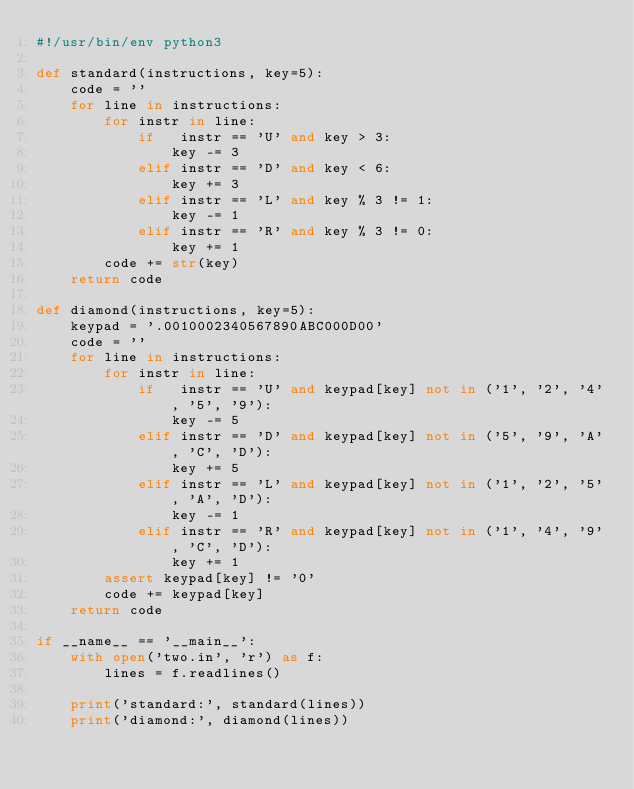Convert code to text. <code><loc_0><loc_0><loc_500><loc_500><_Python_>#!/usr/bin/env python3

def standard(instructions, key=5):
    code = ''
    for line in instructions:
        for instr in line:
            if   instr == 'U' and key > 3:
                key -= 3
            elif instr == 'D' and key < 6:
                key += 3
            elif instr == 'L' and key % 3 != 1:
                key -= 1
            elif instr == 'R' and key % 3 != 0:
                key += 1
        code += str(key)
    return code

def diamond(instructions, key=5):
    keypad = '.0010002340567890ABC000D00'
    code = ''
    for line in instructions:
        for instr in line:
            if   instr == 'U' and keypad[key] not in ('1', '2', '4', '5', '9'):
                key -= 5
            elif instr == 'D' and keypad[key] not in ('5', '9', 'A', 'C', 'D'):
                key += 5
            elif instr == 'L' and keypad[key] not in ('1', '2', '5', 'A', 'D'):
                key -= 1
            elif instr == 'R' and keypad[key] not in ('1', '4', '9', 'C', 'D'):
                key += 1
        assert keypad[key] != '0'
        code += keypad[key]
    return code

if __name__ == '__main__':
    with open('two.in', 'r') as f:
        lines = f.readlines()

    print('standard:', standard(lines))
    print('diamond:', diamond(lines))
</code> 